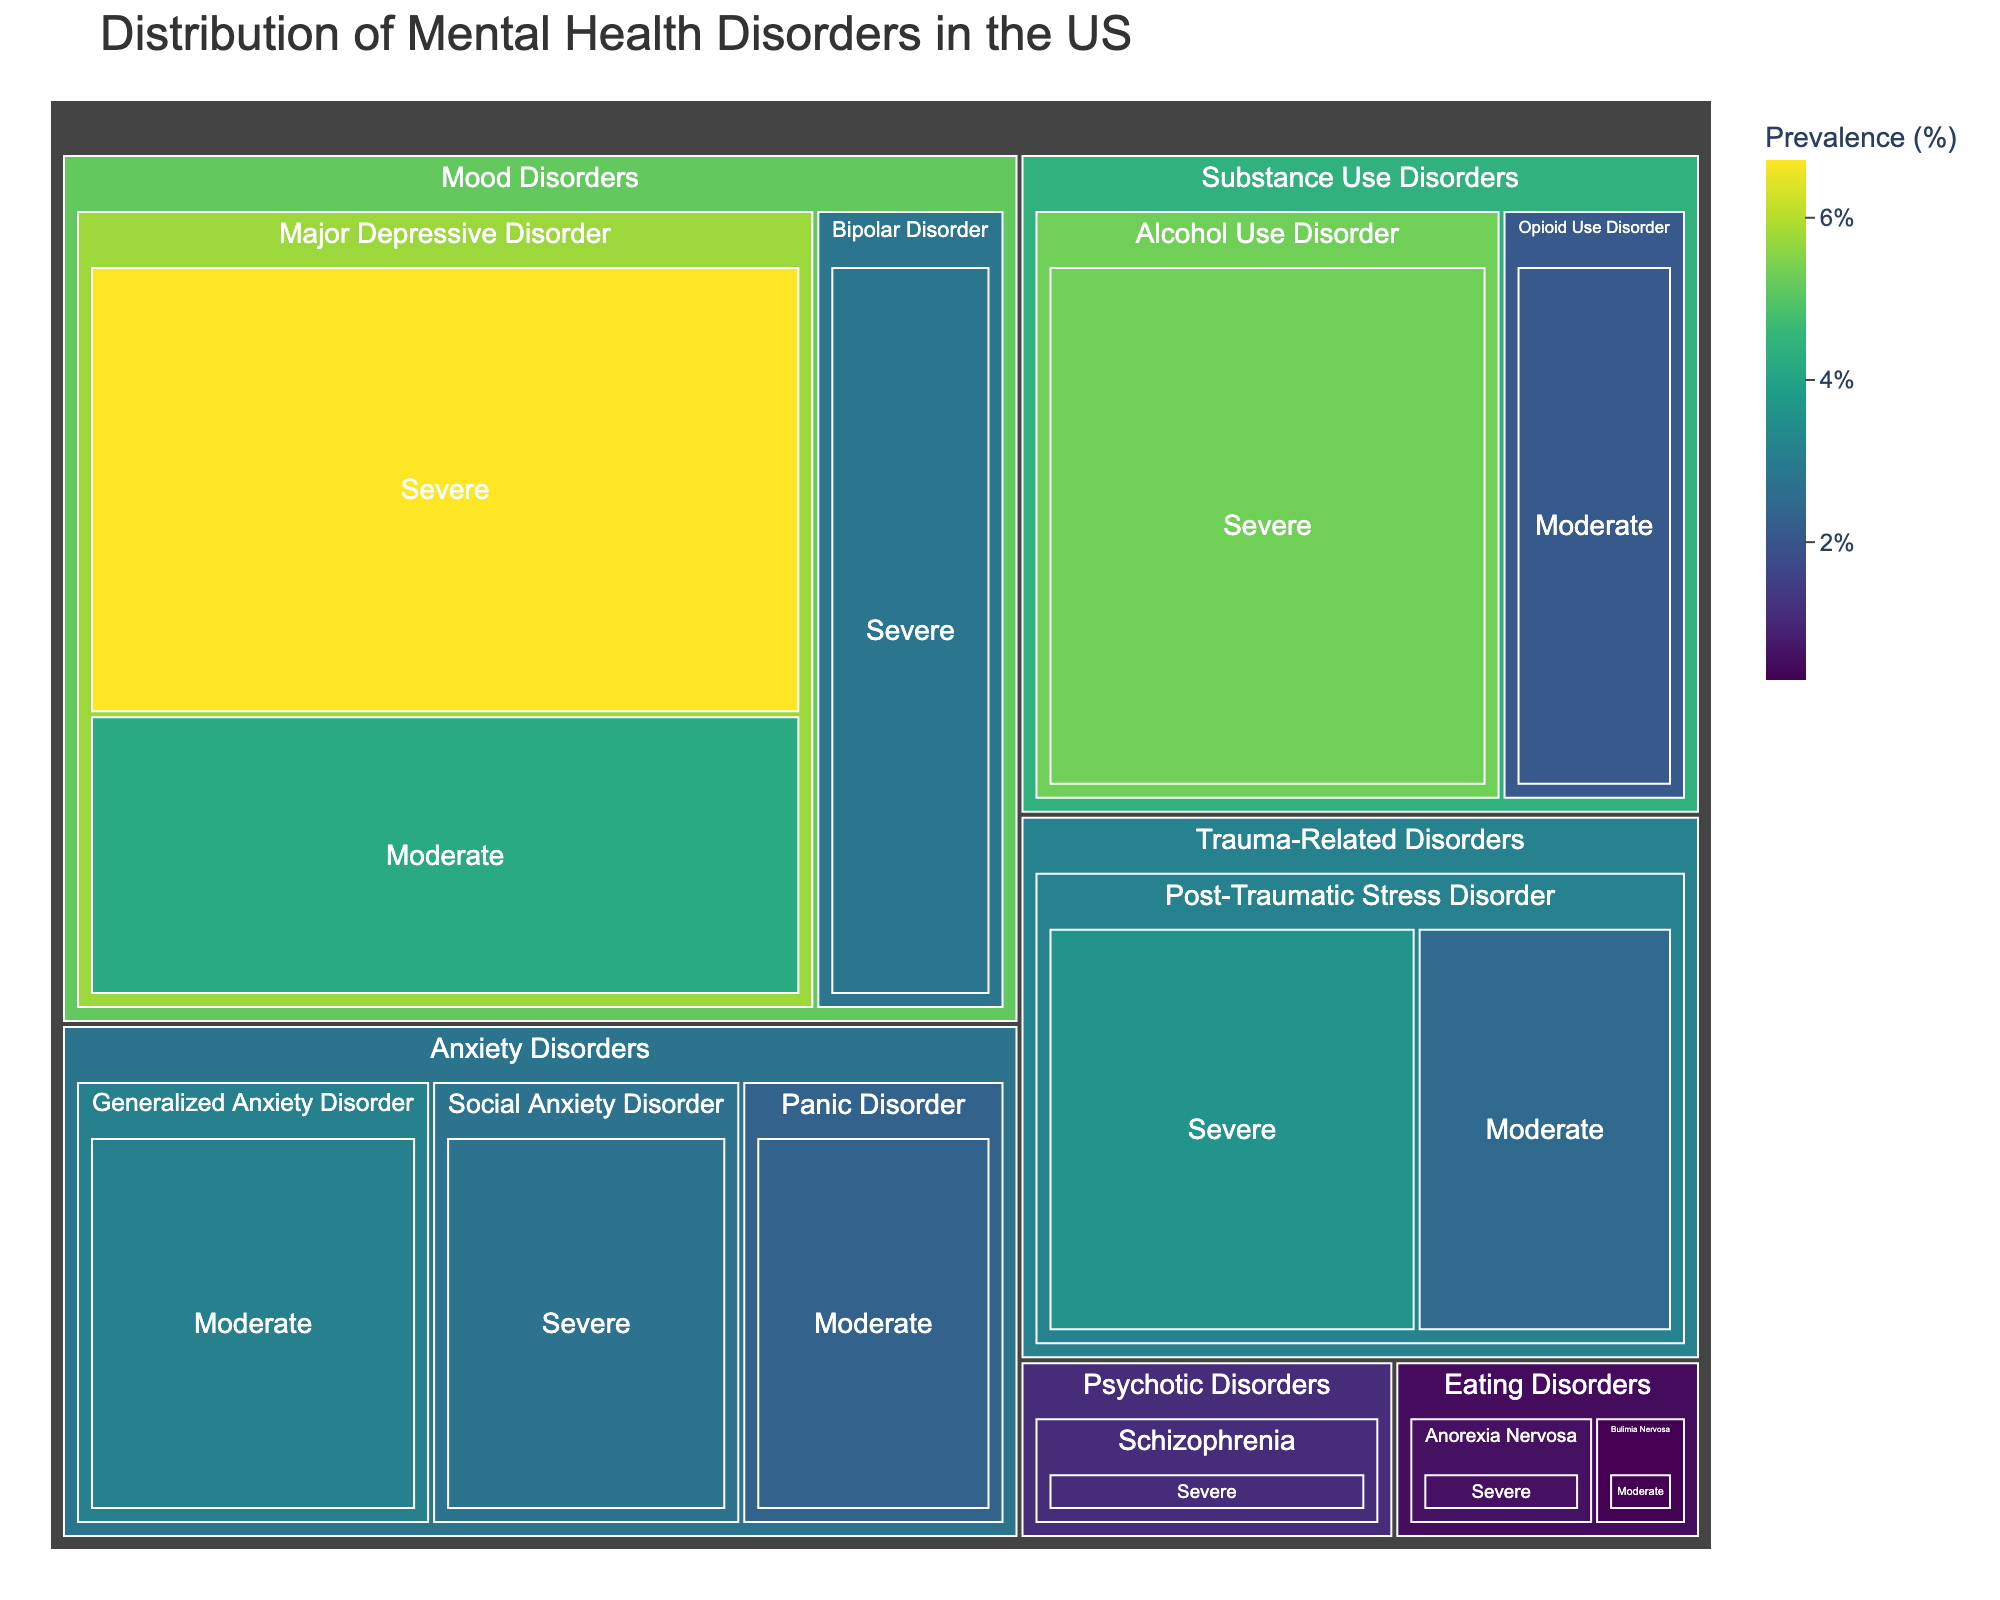what does the title of the figure indicate? The title provides a broad overview, indicating that the figure shows the distribution of various mental health disorders in the US, categorized by type and severity. This establishes a foundational understanding of what the figure represents.
Answer: Distribution of Mental Health Disorders in the US what is the color theme used in the figure? The color theme helps in distinguishing different prevalence rates. In this figure, different shades from a Viridis color scale are used to represent the prevalence percentages.
Answer: Viridis how many main categories of mental health disorders are displayed? By looking at the highest hierarchical level in the treemap, the number of main categories of mental health disorders can be identified.
Answer: 5 which mental health disorder has the highest prevalence? Identify the largest tile in the treemap or the one with the darkest green shade, indicating the highest prevalence percentage among the disorders.
Answer: Major Depressive Disorder, Severe how does the prevalence of panic disorder compare to social anxiety disorder? By scanning the tiles for both disorders and comparing their size and color, we can determine which has a higher or lower prevalence.
Answer: Panic Disorder has a lower prevalence than Social Anxiety Disorder what is the prevalence of moderate major depressive disorder? Locate the tile corresponding to moderate major depressive disorder and read off the prevalence percentage from the figure.
Answer: 4.2% which category has the smallest total prevalence, eating disorders or psychotic disorders? Summing the individual prevalence rates for each disorder within 'Eating Disorders' and 'Psychotic Disorders' categories and then comparing the totals will give the answer.
Answer: Eating Disorders how would you describe the distribution of severe disorders vs moderate disorders? By examining the sizes and colors of the tiles labeled with 'Severe' and 'Moderate' within the categories, we can analyze the relative distribution of severe versus moderate disorders.
Answer: Severe disorders generally have higher prevalence rates what's the combined prevalence of severe and moderate bipolar disorder? Sum the prevalence rates for severe and moderate bipolar disorder by locating both the tiles and adding their values.
Answer: 2.8% (only severe, moderate is not listed) which is more prevalent, alcohol use disorder or generalized anxiety disorder? Locate the tiles for both alcohol use disorder and generalized anxiety disorder, and compare their prevalence percentages.
Answer: Alcohol Use Disorder 